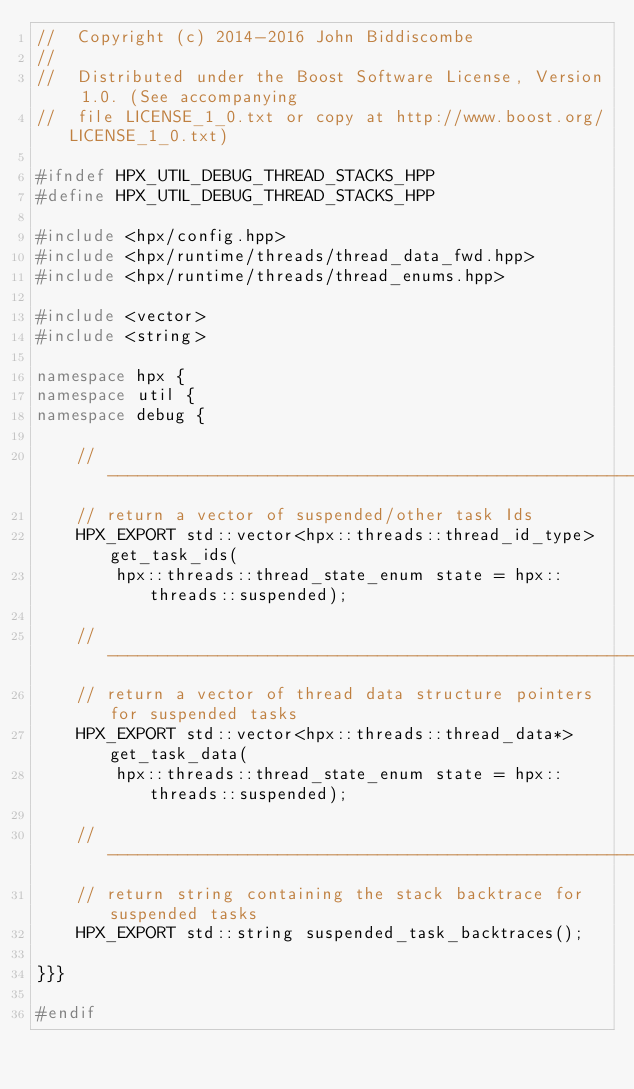Convert code to text. <code><loc_0><loc_0><loc_500><loc_500><_C++_>//  Copyright (c) 2014-2016 John Biddiscombe
//
//  Distributed under the Boost Software License, Version 1.0. (See accompanying
//  file LICENSE_1_0.txt or copy at http://www.boost.org/LICENSE_1_0.txt)

#ifndef HPX_UTIL_DEBUG_THREAD_STACKS_HPP
#define HPX_UTIL_DEBUG_THREAD_STACKS_HPP

#include <hpx/config.hpp>
#include <hpx/runtime/threads/thread_data_fwd.hpp>
#include <hpx/runtime/threads/thread_enums.hpp>

#include <vector>
#include <string>

namespace hpx {
namespace util {
namespace debug {

    // ------------------------------------------------------------------------
    // return a vector of suspended/other task Ids
    HPX_EXPORT std::vector<hpx::threads::thread_id_type> get_task_ids(
        hpx::threads::thread_state_enum state = hpx::threads::suspended);

    // ------------------------------------------------------------------------
    // return a vector of thread data structure pointers for suspended tasks
    HPX_EXPORT std::vector<hpx::threads::thread_data*> get_task_data(
        hpx::threads::thread_state_enum state = hpx::threads::suspended);

    // ------------------------------------------------------------------------
    // return string containing the stack backtrace for suspended tasks
    HPX_EXPORT std::string suspended_task_backtraces();

}}}

#endif

</code> 